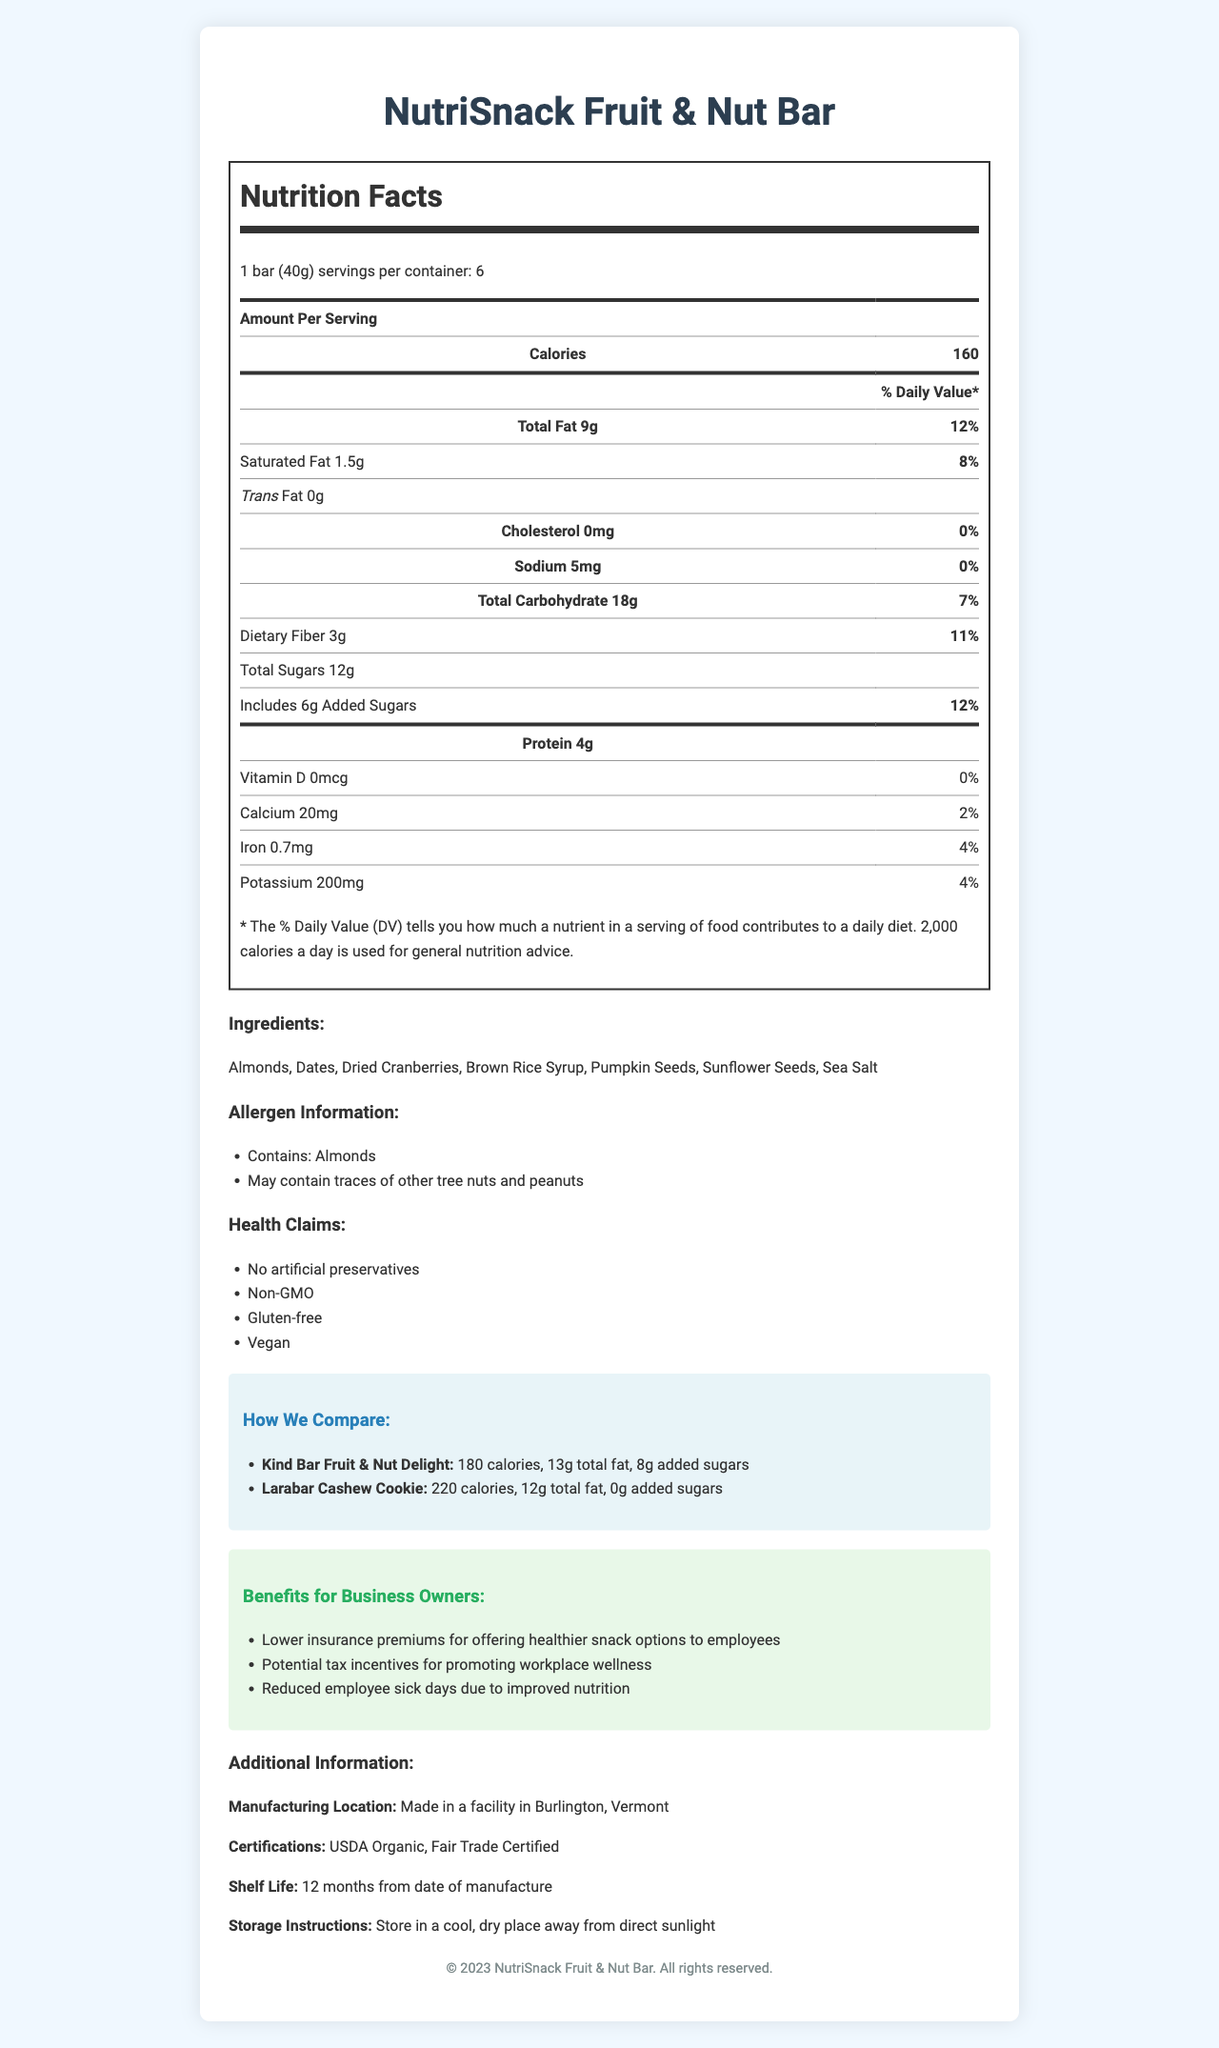what is the serving size of the NutriSnack Fruit & Nut Bar? The serving size is clearly mentioned under the product name in the nutrition facts label.
Answer: 1 bar (40g) how many calories are there per serving of NutriSnack Fruit & Nut Bar? The calories per serving are displayed prominently in the nutrition facts table.
Answer: 160 what are the total fat and saturated fat contents per serving? These values are listed in the nutrition facts label under the "Total Fat" section.
Answer: Total Fat: 9g, Saturated Fat: 1.5g how much dietary fiber is in one NutriSnack Fruit & Nut Bar? The dietary fiber content is listed under the "Total Carbohydrate" section in the nutrition facts.
Answer: 3g which certifications does the NutriSnack Fruit & Nut Bar have? The certifications are listed in the "Additional Information" section of the document.
Answer: USDA Organic, Fair Trade Certified between NutriSnack Fruit & Nut Bar and Kind Bar Fruit & Nut Delight, which one has more calories? A. NutriSnack Fruit & Nut Bar B. Kind Bar Fruit & Nut Delight The Kind Bar Fruit & Nut Delight has 180 calories whereas the NutriSnack Fruit & Nut Bar has 160 calories.
Answer: B which health claim is not associated with the NutriSnack Fruit & Nut Bar? A. Gluten-free B. No artificial preservatives C. Contains dairy D. Non-GMO All listed claims except "Contains dairy" are mentioned in the health claims of the NutriSnack Fruit & Nut Bar.
Answer: C does the NutriSnack Fruit & Nut Bar contain added sugars? The nutrition facts label states that there are 6g of added sugars.
Answer: Yes is the NutriSnack Fruit & Nut Bar vegan? The document lists "Vegan" under the health claims section.
Answer: Yes summarize the main idea of this document. The document is an informative overview focusing on the nutritional value, ingredients, comparative advantages, and business benefits of the NutriSnack Fruit & Nut Bar.
Answer: The document provides detailed information about the NutriSnack Fruit & Nut Bar, including its nutritional content, ingredients, allergens, health claims, certifications, and a comparison with competitor products. It also highlights the benefits for business owners and additional product details. what is the price per container of NutriSnack Fruit & Nut Bar? The document does not provide any information regarding the price of the NutriSnack Fruit & Nut Bar.
Answer: Cannot be determined 